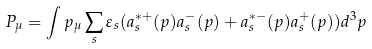<formula> <loc_0><loc_0><loc_500><loc_500>P _ { \mu } = \int p _ { \mu } \sum _ { s } \varepsilon _ { s } ( a _ { s } ^ { * + } ( p ) a _ { s } ^ { - } ( p ) + a _ { s } ^ { * - } ( p ) a _ { s } ^ { + } ( p ) ) d ^ { 3 } p</formula> 